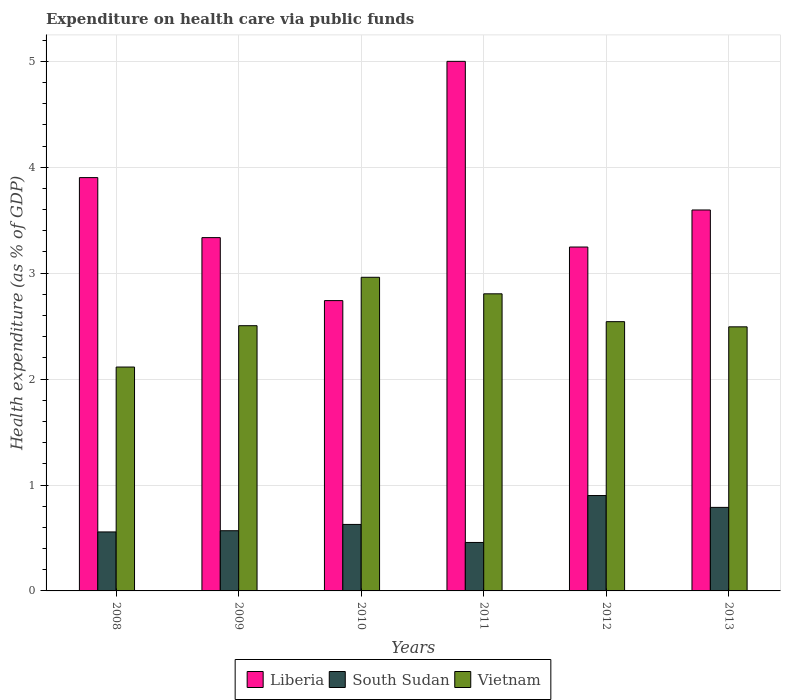How many different coloured bars are there?
Offer a terse response. 3. Are the number of bars on each tick of the X-axis equal?
Give a very brief answer. Yes. What is the label of the 2nd group of bars from the left?
Keep it short and to the point. 2009. In how many cases, is the number of bars for a given year not equal to the number of legend labels?
Offer a very short reply. 0. What is the expenditure made on health care in Vietnam in 2008?
Keep it short and to the point. 2.11. Across all years, what is the maximum expenditure made on health care in Liberia?
Offer a very short reply. 5. Across all years, what is the minimum expenditure made on health care in Vietnam?
Keep it short and to the point. 2.11. What is the total expenditure made on health care in Vietnam in the graph?
Your response must be concise. 15.42. What is the difference between the expenditure made on health care in Vietnam in 2010 and that in 2013?
Make the answer very short. 0.47. What is the difference between the expenditure made on health care in Liberia in 2008 and the expenditure made on health care in South Sudan in 2009?
Provide a succinct answer. 3.33. What is the average expenditure made on health care in Vietnam per year?
Offer a terse response. 2.57. In the year 2012, what is the difference between the expenditure made on health care in Liberia and expenditure made on health care in South Sudan?
Your response must be concise. 2.35. What is the ratio of the expenditure made on health care in Liberia in 2009 to that in 2011?
Give a very brief answer. 0.67. Is the expenditure made on health care in Vietnam in 2010 less than that in 2012?
Provide a succinct answer. No. What is the difference between the highest and the second highest expenditure made on health care in South Sudan?
Give a very brief answer. 0.11. What is the difference between the highest and the lowest expenditure made on health care in Vietnam?
Keep it short and to the point. 0.85. Is the sum of the expenditure made on health care in South Sudan in 2012 and 2013 greater than the maximum expenditure made on health care in Vietnam across all years?
Your answer should be very brief. No. What does the 3rd bar from the left in 2010 represents?
Give a very brief answer. Vietnam. What does the 1st bar from the right in 2010 represents?
Your answer should be compact. Vietnam. How many bars are there?
Ensure brevity in your answer.  18. Are all the bars in the graph horizontal?
Your answer should be very brief. No. What is the difference between two consecutive major ticks on the Y-axis?
Provide a short and direct response. 1. Does the graph contain grids?
Offer a terse response. Yes. How are the legend labels stacked?
Offer a terse response. Horizontal. What is the title of the graph?
Provide a succinct answer. Expenditure on health care via public funds. What is the label or title of the X-axis?
Make the answer very short. Years. What is the label or title of the Y-axis?
Your answer should be compact. Health expenditure (as % of GDP). What is the Health expenditure (as % of GDP) in Liberia in 2008?
Your answer should be very brief. 3.9. What is the Health expenditure (as % of GDP) of South Sudan in 2008?
Keep it short and to the point. 0.56. What is the Health expenditure (as % of GDP) in Vietnam in 2008?
Your response must be concise. 2.11. What is the Health expenditure (as % of GDP) of Liberia in 2009?
Provide a short and direct response. 3.34. What is the Health expenditure (as % of GDP) in South Sudan in 2009?
Provide a succinct answer. 0.57. What is the Health expenditure (as % of GDP) in Vietnam in 2009?
Your response must be concise. 2.5. What is the Health expenditure (as % of GDP) in Liberia in 2010?
Offer a terse response. 2.74. What is the Health expenditure (as % of GDP) in South Sudan in 2010?
Your response must be concise. 0.63. What is the Health expenditure (as % of GDP) of Vietnam in 2010?
Provide a succinct answer. 2.96. What is the Health expenditure (as % of GDP) in Liberia in 2011?
Ensure brevity in your answer.  5. What is the Health expenditure (as % of GDP) in South Sudan in 2011?
Ensure brevity in your answer.  0.46. What is the Health expenditure (as % of GDP) in Vietnam in 2011?
Offer a terse response. 2.81. What is the Health expenditure (as % of GDP) of Liberia in 2012?
Your answer should be very brief. 3.25. What is the Health expenditure (as % of GDP) of South Sudan in 2012?
Make the answer very short. 0.9. What is the Health expenditure (as % of GDP) of Vietnam in 2012?
Keep it short and to the point. 2.54. What is the Health expenditure (as % of GDP) of Liberia in 2013?
Ensure brevity in your answer.  3.6. What is the Health expenditure (as % of GDP) in South Sudan in 2013?
Ensure brevity in your answer.  0.79. What is the Health expenditure (as % of GDP) of Vietnam in 2013?
Provide a short and direct response. 2.49. Across all years, what is the maximum Health expenditure (as % of GDP) in Liberia?
Your answer should be compact. 5. Across all years, what is the maximum Health expenditure (as % of GDP) in South Sudan?
Ensure brevity in your answer.  0.9. Across all years, what is the maximum Health expenditure (as % of GDP) in Vietnam?
Provide a succinct answer. 2.96. Across all years, what is the minimum Health expenditure (as % of GDP) of Liberia?
Provide a short and direct response. 2.74. Across all years, what is the minimum Health expenditure (as % of GDP) in South Sudan?
Your answer should be very brief. 0.46. Across all years, what is the minimum Health expenditure (as % of GDP) of Vietnam?
Your answer should be compact. 2.11. What is the total Health expenditure (as % of GDP) in Liberia in the graph?
Give a very brief answer. 21.82. What is the total Health expenditure (as % of GDP) in South Sudan in the graph?
Your answer should be compact. 3.9. What is the total Health expenditure (as % of GDP) in Vietnam in the graph?
Keep it short and to the point. 15.42. What is the difference between the Health expenditure (as % of GDP) of Liberia in 2008 and that in 2009?
Provide a short and direct response. 0.57. What is the difference between the Health expenditure (as % of GDP) in South Sudan in 2008 and that in 2009?
Provide a succinct answer. -0.01. What is the difference between the Health expenditure (as % of GDP) of Vietnam in 2008 and that in 2009?
Offer a terse response. -0.39. What is the difference between the Health expenditure (as % of GDP) in Liberia in 2008 and that in 2010?
Provide a short and direct response. 1.16. What is the difference between the Health expenditure (as % of GDP) in South Sudan in 2008 and that in 2010?
Keep it short and to the point. -0.07. What is the difference between the Health expenditure (as % of GDP) in Vietnam in 2008 and that in 2010?
Make the answer very short. -0.85. What is the difference between the Health expenditure (as % of GDP) of Liberia in 2008 and that in 2011?
Make the answer very short. -1.1. What is the difference between the Health expenditure (as % of GDP) of South Sudan in 2008 and that in 2011?
Offer a very short reply. 0.1. What is the difference between the Health expenditure (as % of GDP) of Vietnam in 2008 and that in 2011?
Ensure brevity in your answer.  -0.69. What is the difference between the Health expenditure (as % of GDP) in Liberia in 2008 and that in 2012?
Ensure brevity in your answer.  0.66. What is the difference between the Health expenditure (as % of GDP) in South Sudan in 2008 and that in 2012?
Ensure brevity in your answer.  -0.34. What is the difference between the Health expenditure (as % of GDP) in Vietnam in 2008 and that in 2012?
Offer a terse response. -0.43. What is the difference between the Health expenditure (as % of GDP) of Liberia in 2008 and that in 2013?
Give a very brief answer. 0.31. What is the difference between the Health expenditure (as % of GDP) of South Sudan in 2008 and that in 2013?
Offer a very short reply. -0.23. What is the difference between the Health expenditure (as % of GDP) in Vietnam in 2008 and that in 2013?
Your answer should be compact. -0.38. What is the difference between the Health expenditure (as % of GDP) of Liberia in 2009 and that in 2010?
Your response must be concise. 0.59. What is the difference between the Health expenditure (as % of GDP) of South Sudan in 2009 and that in 2010?
Your answer should be compact. -0.06. What is the difference between the Health expenditure (as % of GDP) in Vietnam in 2009 and that in 2010?
Your answer should be compact. -0.46. What is the difference between the Health expenditure (as % of GDP) of Liberia in 2009 and that in 2011?
Make the answer very short. -1.66. What is the difference between the Health expenditure (as % of GDP) of South Sudan in 2009 and that in 2011?
Provide a succinct answer. 0.11. What is the difference between the Health expenditure (as % of GDP) of Vietnam in 2009 and that in 2011?
Your answer should be compact. -0.3. What is the difference between the Health expenditure (as % of GDP) in Liberia in 2009 and that in 2012?
Your response must be concise. 0.09. What is the difference between the Health expenditure (as % of GDP) in South Sudan in 2009 and that in 2012?
Keep it short and to the point. -0.33. What is the difference between the Health expenditure (as % of GDP) in Vietnam in 2009 and that in 2012?
Offer a very short reply. -0.04. What is the difference between the Health expenditure (as % of GDP) in Liberia in 2009 and that in 2013?
Give a very brief answer. -0.26. What is the difference between the Health expenditure (as % of GDP) of South Sudan in 2009 and that in 2013?
Keep it short and to the point. -0.22. What is the difference between the Health expenditure (as % of GDP) of Vietnam in 2009 and that in 2013?
Your answer should be compact. 0.01. What is the difference between the Health expenditure (as % of GDP) in Liberia in 2010 and that in 2011?
Offer a very short reply. -2.26. What is the difference between the Health expenditure (as % of GDP) in South Sudan in 2010 and that in 2011?
Offer a terse response. 0.17. What is the difference between the Health expenditure (as % of GDP) of Vietnam in 2010 and that in 2011?
Provide a succinct answer. 0.16. What is the difference between the Health expenditure (as % of GDP) in Liberia in 2010 and that in 2012?
Keep it short and to the point. -0.51. What is the difference between the Health expenditure (as % of GDP) in South Sudan in 2010 and that in 2012?
Make the answer very short. -0.27. What is the difference between the Health expenditure (as % of GDP) of Vietnam in 2010 and that in 2012?
Keep it short and to the point. 0.42. What is the difference between the Health expenditure (as % of GDP) in Liberia in 2010 and that in 2013?
Give a very brief answer. -0.86. What is the difference between the Health expenditure (as % of GDP) in South Sudan in 2010 and that in 2013?
Provide a short and direct response. -0.16. What is the difference between the Health expenditure (as % of GDP) of Vietnam in 2010 and that in 2013?
Offer a very short reply. 0.47. What is the difference between the Health expenditure (as % of GDP) in Liberia in 2011 and that in 2012?
Your answer should be compact. 1.75. What is the difference between the Health expenditure (as % of GDP) in South Sudan in 2011 and that in 2012?
Ensure brevity in your answer.  -0.44. What is the difference between the Health expenditure (as % of GDP) in Vietnam in 2011 and that in 2012?
Offer a terse response. 0.26. What is the difference between the Health expenditure (as % of GDP) in Liberia in 2011 and that in 2013?
Your response must be concise. 1.4. What is the difference between the Health expenditure (as % of GDP) in South Sudan in 2011 and that in 2013?
Provide a short and direct response. -0.33. What is the difference between the Health expenditure (as % of GDP) in Vietnam in 2011 and that in 2013?
Offer a terse response. 0.31. What is the difference between the Health expenditure (as % of GDP) of Liberia in 2012 and that in 2013?
Give a very brief answer. -0.35. What is the difference between the Health expenditure (as % of GDP) in South Sudan in 2012 and that in 2013?
Your answer should be compact. 0.11. What is the difference between the Health expenditure (as % of GDP) of Vietnam in 2012 and that in 2013?
Keep it short and to the point. 0.05. What is the difference between the Health expenditure (as % of GDP) of Liberia in 2008 and the Health expenditure (as % of GDP) of South Sudan in 2009?
Make the answer very short. 3.33. What is the difference between the Health expenditure (as % of GDP) in Liberia in 2008 and the Health expenditure (as % of GDP) in Vietnam in 2009?
Offer a very short reply. 1.4. What is the difference between the Health expenditure (as % of GDP) in South Sudan in 2008 and the Health expenditure (as % of GDP) in Vietnam in 2009?
Provide a succinct answer. -1.95. What is the difference between the Health expenditure (as % of GDP) of Liberia in 2008 and the Health expenditure (as % of GDP) of South Sudan in 2010?
Provide a succinct answer. 3.27. What is the difference between the Health expenditure (as % of GDP) of Liberia in 2008 and the Health expenditure (as % of GDP) of Vietnam in 2010?
Keep it short and to the point. 0.94. What is the difference between the Health expenditure (as % of GDP) in South Sudan in 2008 and the Health expenditure (as % of GDP) in Vietnam in 2010?
Offer a terse response. -2.4. What is the difference between the Health expenditure (as % of GDP) in Liberia in 2008 and the Health expenditure (as % of GDP) in South Sudan in 2011?
Offer a terse response. 3.44. What is the difference between the Health expenditure (as % of GDP) in Liberia in 2008 and the Health expenditure (as % of GDP) in Vietnam in 2011?
Give a very brief answer. 1.1. What is the difference between the Health expenditure (as % of GDP) of South Sudan in 2008 and the Health expenditure (as % of GDP) of Vietnam in 2011?
Offer a terse response. -2.25. What is the difference between the Health expenditure (as % of GDP) in Liberia in 2008 and the Health expenditure (as % of GDP) in South Sudan in 2012?
Your answer should be compact. 3. What is the difference between the Health expenditure (as % of GDP) of Liberia in 2008 and the Health expenditure (as % of GDP) of Vietnam in 2012?
Ensure brevity in your answer.  1.36. What is the difference between the Health expenditure (as % of GDP) in South Sudan in 2008 and the Health expenditure (as % of GDP) in Vietnam in 2012?
Give a very brief answer. -1.99. What is the difference between the Health expenditure (as % of GDP) in Liberia in 2008 and the Health expenditure (as % of GDP) in South Sudan in 2013?
Your answer should be compact. 3.11. What is the difference between the Health expenditure (as % of GDP) in Liberia in 2008 and the Health expenditure (as % of GDP) in Vietnam in 2013?
Give a very brief answer. 1.41. What is the difference between the Health expenditure (as % of GDP) of South Sudan in 2008 and the Health expenditure (as % of GDP) of Vietnam in 2013?
Give a very brief answer. -1.94. What is the difference between the Health expenditure (as % of GDP) of Liberia in 2009 and the Health expenditure (as % of GDP) of South Sudan in 2010?
Provide a short and direct response. 2.71. What is the difference between the Health expenditure (as % of GDP) in Liberia in 2009 and the Health expenditure (as % of GDP) in Vietnam in 2010?
Offer a terse response. 0.37. What is the difference between the Health expenditure (as % of GDP) of South Sudan in 2009 and the Health expenditure (as % of GDP) of Vietnam in 2010?
Offer a terse response. -2.39. What is the difference between the Health expenditure (as % of GDP) in Liberia in 2009 and the Health expenditure (as % of GDP) in South Sudan in 2011?
Make the answer very short. 2.88. What is the difference between the Health expenditure (as % of GDP) in Liberia in 2009 and the Health expenditure (as % of GDP) in Vietnam in 2011?
Keep it short and to the point. 0.53. What is the difference between the Health expenditure (as % of GDP) in South Sudan in 2009 and the Health expenditure (as % of GDP) in Vietnam in 2011?
Give a very brief answer. -2.24. What is the difference between the Health expenditure (as % of GDP) of Liberia in 2009 and the Health expenditure (as % of GDP) of South Sudan in 2012?
Your response must be concise. 2.44. What is the difference between the Health expenditure (as % of GDP) in Liberia in 2009 and the Health expenditure (as % of GDP) in Vietnam in 2012?
Offer a terse response. 0.79. What is the difference between the Health expenditure (as % of GDP) in South Sudan in 2009 and the Health expenditure (as % of GDP) in Vietnam in 2012?
Your answer should be compact. -1.97. What is the difference between the Health expenditure (as % of GDP) in Liberia in 2009 and the Health expenditure (as % of GDP) in South Sudan in 2013?
Keep it short and to the point. 2.55. What is the difference between the Health expenditure (as % of GDP) in Liberia in 2009 and the Health expenditure (as % of GDP) in Vietnam in 2013?
Give a very brief answer. 0.84. What is the difference between the Health expenditure (as % of GDP) of South Sudan in 2009 and the Health expenditure (as % of GDP) of Vietnam in 2013?
Offer a very short reply. -1.93. What is the difference between the Health expenditure (as % of GDP) in Liberia in 2010 and the Health expenditure (as % of GDP) in South Sudan in 2011?
Your answer should be very brief. 2.28. What is the difference between the Health expenditure (as % of GDP) of Liberia in 2010 and the Health expenditure (as % of GDP) of Vietnam in 2011?
Your answer should be compact. -0.06. What is the difference between the Health expenditure (as % of GDP) in South Sudan in 2010 and the Health expenditure (as % of GDP) in Vietnam in 2011?
Provide a succinct answer. -2.18. What is the difference between the Health expenditure (as % of GDP) in Liberia in 2010 and the Health expenditure (as % of GDP) in South Sudan in 2012?
Your answer should be very brief. 1.84. What is the difference between the Health expenditure (as % of GDP) of Liberia in 2010 and the Health expenditure (as % of GDP) of Vietnam in 2012?
Offer a very short reply. 0.2. What is the difference between the Health expenditure (as % of GDP) of South Sudan in 2010 and the Health expenditure (as % of GDP) of Vietnam in 2012?
Keep it short and to the point. -1.91. What is the difference between the Health expenditure (as % of GDP) in Liberia in 2010 and the Health expenditure (as % of GDP) in South Sudan in 2013?
Offer a very short reply. 1.95. What is the difference between the Health expenditure (as % of GDP) of Liberia in 2010 and the Health expenditure (as % of GDP) of Vietnam in 2013?
Provide a short and direct response. 0.25. What is the difference between the Health expenditure (as % of GDP) of South Sudan in 2010 and the Health expenditure (as % of GDP) of Vietnam in 2013?
Offer a terse response. -1.87. What is the difference between the Health expenditure (as % of GDP) of Liberia in 2011 and the Health expenditure (as % of GDP) of South Sudan in 2012?
Your response must be concise. 4.1. What is the difference between the Health expenditure (as % of GDP) in Liberia in 2011 and the Health expenditure (as % of GDP) in Vietnam in 2012?
Provide a succinct answer. 2.46. What is the difference between the Health expenditure (as % of GDP) of South Sudan in 2011 and the Health expenditure (as % of GDP) of Vietnam in 2012?
Ensure brevity in your answer.  -2.08. What is the difference between the Health expenditure (as % of GDP) of Liberia in 2011 and the Health expenditure (as % of GDP) of South Sudan in 2013?
Keep it short and to the point. 4.21. What is the difference between the Health expenditure (as % of GDP) in Liberia in 2011 and the Health expenditure (as % of GDP) in Vietnam in 2013?
Give a very brief answer. 2.51. What is the difference between the Health expenditure (as % of GDP) in South Sudan in 2011 and the Health expenditure (as % of GDP) in Vietnam in 2013?
Keep it short and to the point. -2.04. What is the difference between the Health expenditure (as % of GDP) in Liberia in 2012 and the Health expenditure (as % of GDP) in South Sudan in 2013?
Your response must be concise. 2.46. What is the difference between the Health expenditure (as % of GDP) in Liberia in 2012 and the Health expenditure (as % of GDP) in Vietnam in 2013?
Make the answer very short. 0.75. What is the difference between the Health expenditure (as % of GDP) in South Sudan in 2012 and the Health expenditure (as % of GDP) in Vietnam in 2013?
Offer a terse response. -1.59. What is the average Health expenditure (as % of GDP) of Liberia per year?
Your answer should be very brief. 3.64. What is the average Health expenditure (as % of GDP) of South Sudan per year?
Offer a terse response. 0.65. What is the average Health expenditure (as % of GDP) in Vietnam per year?
Make the answer very short. 2.57. In the year 2008, what is the difference between the Health expenditure (as % of GDP) of Liberia and Health expenditure (as % of GDP) of South Sudan?
Your response must be concise. 3.35. In the year 2008, what is the difference between the Health expenditure (as % of GDP) of Liberia and Health expenditure (as % of GDP) of Vietnam?
Offer a very short reply. 1.79. In the year 2008, what is the difference between the Health expenditure (as % of GDP) of South Sudan and Health expenditure (as % of GDP) of Vietnam?
Keep it short and to the point. -1.56. In the year 2009, what is the difference between the Health expenditure (as % of GDP) of Liberia and Health expenditure (as % of GDP) of South Sudan?
Offer a terse response. 2.77. In the year 2009, what is the difference between the Health expenditure (as % of GDP) of Liberia and Health expenditure (as % of GDP) of Vietnam?
Ensure brevity in your answer.  0.83. In the year 2009, what is the difference between the Health expenditure (as % of GDP) of South Sudan and Health expenditure (as % of GDP) of Vietnam?
Provide a succinct answer. -1.94. In the year 2010, what is the difference between the Health expenditure (as % of GDP) of Liberia and Health expenditure (as % of GDP) of South Sudan?
Provide a succinct answer. 2.11. In the year 2010, what is the difference between the Health expenditure (as % of GDP) in Liberia and Health expenditure (as % of GDP) in Vietnam?
Ensure brevity in your answer.  -0.22. In the year 2010, what is the difference between the Health expenditure (as % of GDP) in South Sudan and Health expenditure (as % of GDP) in Vietnam?
Make the answer very short. -2.33. In the year 2011, what is the difference between the Health expenditure (as % of GDP) of Liberia and Health expenditure (as % of GDP) of South Sudan?
Your answer should be very brief. 4.54. In the year 2011, what is the difference between the Health expenditure (as % of GDP) in Liberia and Health expenditure (as % of GDP) in Vietnam?
Your answer should be very brief. 2.19. In the year 2011, what is the difference between the Health expenditure (as % of GDP) of South Sudan and Health expenditure (as % of GDP) of Vietnam?
Provide a short and direct response. -2.35. In the year 2012, what is the difference between the Health expenditure (as % of GDP) of Liberia and Health expenditure (as % of GDP) of South Sudan?
Keep it short and to the point. 2.35. In the year 2012, what is the difference between the Health expenditure (as % of GDP) in Liberia and Health expenditure (as % of GDP) in Vietnam?
Keep it short and to the point. 0.7. In the year 2012, what is the difference between the Health expenditure (as % of GDP) of South Sudan and Health expenditure (as % of GDP) of Vietnam?
Make the answer very short. -1.64. In the year 2013, what is the difference between the Health expenditure (as % of GDP) in Liberia and Health expenditure (as % of GDP) in South Sudan?
Provide a succinct answer. 2.81. In the year 2013, what is the difference between the Health expenditure (as % of GDP) of Liberia and Health expenditure (as % of GDP) of Vietnam?
Keep it short and to the point. 1.1. In the year 2013, what is the difference between the Health expenditure (as % of GDP) of South Sudan and Health expenditure (as % of GDP) of Vietnam?
Make the answer very short. -1.7. What is the ratio of the Health expenditure (as % of GDP) of Liberia in 2008 to that in 2009?
Offer a very short reply. 1.17. What is the ratio of the Health expenditure (as % of GDP) in South Sudan in 2008 to that in 2009?
Ensure brevity in your answer.  0.98. What is the ratio of the Health expenditure (as % of GDP) of Vietnam in 2008 to that in 2009?
Your answer should be very brief. 0.84. What is the ratio of the Health expenditure (as % of GDP) of Liberia in 2008 to that in 2010?
Your answer should be compact. 1.42. What is the ratio of the Health expenditure (as % of GDP) in South Sudan in 2008 to that in 2010?
Keep it short and to the point. 0.89. What is the ratio of the Health expenditure (as % of GDP) of Vietnam in 2008 to that in 2010?
Give a very brief answer. 0.71. What is the ratio of the Health expenditure (as % of GDP) in Liberia in 2008 to that in 2011?
Your answer should be compact. 0.78. What is the ratio of the Health expenditure (as % of GDP) in South Sudan in 2008 to that in 2011?
Give a very brief answer. 1.22. What is the ratio of the Health expenditure (as % of GDP) of Vietnam in 2008 to that in 2011?
Make the answer very short. 0.75. What is the ratio of the Health expenditure (as % of GDP) in Liberia in 2008 to that in 2012?
Your answer should be very brief. 1.2. What is the ratio of the Health expenditure (as % of GDP) in South Sudan in 2008 to that in 2012?
Your response must be concise. 0.62. What is the ratio of the Health expenditure (as % of GDP) of Vietnam in 2008 to that in 2012?
Your answer should be compact. 0.83. What is the ratio of the Health expenditure (as % of GDP) in Liberia in 2008 to that in 2013?
Your response must be concise. 1.08. What is the ratio of the Health expenditure (as % of GDP) in South Sudan in 2008 to that in 2013?
Your answer should be compact. 0.71. What is the ratio of the Health expenditure (as % of GDP) of Vietnam in 2008 to that in 2013?
Ensure brevity in your answer.  0.85. What is the ratio of the Health expenditure (as % of GDP) in Liberia in 2009 to that in 2010?
Ensure brevity in your answer.  1.22. What is the ratio of the Health expenditure (as % of GDP) of South Sudan in 2009 to that in 2010?
Give a very brief answer. 0.91. What is the ratio of the Health expenditure (as % of GDP) in Vietnam in 2009 to that in 2010?
Offer a very short reply. 0.85. What is the ratio of the Health expenditure (as % of GDP) of Liberia in 2009 to that in 2011?
Your answer should be compact. 0.67. What is the ratio of the Health expenditure (as % of GDP) of South Sudan in 2009 to that in 2011?
Make the answer very short. 1.24. What is the ratio of the Health expenditure (as % of GDP) in Vietnam in 2009 to that in 2011?
Give a very brief answer. 0.89. What is the ratio of the Health expenditure (as % of GDP) in Liberia in 2009 to that in 2012?
Your response must be concise. 1.03. What is the ratio of the Health expenditure (as % of GDP) in South Sudan in 2009 to that in 2012?
Keep it short and to the point. 0.63. What is the ratio of the Health expenditure (as % of GDP) of Liberia in 2009 to that in 2013?
Offer a very short reply. 0.93. What is the ratio of the Health expenditure (as % of GDP) in South Sudan in 2009 to that in 2013?
Your answer should be compact. 0.72. What is the ratio of the Health expenditure (as % of GDP) of Vietnam in 2009 to that in 2013?
Offer a very short reply. 1. What is the ratio of the Health expenditure (as % of GDP) in Liberia in 2010 to that in 2011?
Your response must be concise. 0.55. What is the ratio of the Health expenditure (as % of GDP) in South Sudan in 2010 to that in 2011?
Offer a very short reply. 1.37. What is the ratio of the Health expenditure (as % of GDP) of Vietnam in 2010 to that in 2011?
Give a very brief answer. 1.06. What is the ratio of the Health expenditure (as % of GDP) of Liberia in 2010 to that in 2012?
Offer a very short reply. 0.84. What is the ratio of the Health expenditure (as % of GDP) in South Sudan in 2010 to that in 2012?
Ensure brevity in your answer.  0.7. What is the ratio of the Health expenditure (as % of GDP) in Vietnam in 2010 to that in 2012?
Offer a terse response. 1.16. What is the ratio of the Health expenditure (as % of GDP) in Liberia in 2010 to that in 2013?
Offer a terse response. 0.76. What is the ratio of the Health expenditure (as % of GDP) of South Sudan in 2010 to that in 2013?
Offer a very short reply. 0.8. What is the ratio of the Health expenditure (as % of GDP) of Vietnam in 2010 to that in 2013?
Keep it short and to the point. 1.19. What is the ratio of the Health expenditure (as % of GDP) in Liberia in 2011 to that in 2012?
Ensure brevity in your answer.  1.54. What is the ratio of the Health expenditure (as % of GDP) in South Sudan in 2011 to that in 2012?
Provide a succinct answer. 0.51. What is the ratio of the Health expenditure (as % of GDP) of Vietnam in 2011 to that in 2012?
Your response must be concise. 1.1. What is the ratio of the Health expenditure (as % of GDP) in Liberia in 2011 to that in 2013?
Make the answer very short. 1.39. What is the ratio of the Health expenditure (as % of GDP) in South Sudan in 2011 to that in 2013?
Your response must be concise. 0.58. What is the ratio of the Health expenditure (as % of GDP) of Vietnam in 2011 to that in 2013?
Your answer should be compact. 1.12. What is the ratio of the Health expenditure (as % of GDP) in Liberia in 2012 to that in 2013?
Offer a terse response. 0.9. What is the ratio of the Health expenditure (as % of GDP) of South Sudan in 2012 to that in 2013?
Offer a very short reply. 1.14. What is the ratio of the Health expenditure (as % of GDP) in Vietnam in 2012 to that in 2013?
Your answer should be very brief. 1.02. What is the difference between the highest and the second highest Health expenditure (as % of GDP) in Liberia?
Ensure brevity in your answer.  1.1. What is the difference between the highest and the second highest Health expenditure (as % of GDP) in South Sudan?
Provide a short and direct response. 0.11. What is the difference between the highest and the second highest Health expenditure (as % of GDP) of Vietnam?
Keep it short and to the point. 0.16. What is the difference between the highest and the lowest Health expenditure (as % of GDP) of Liberia?
Give a very brief answer. 2.26. What is the difference between the highest and the lowest Health expenditure (as % of GDP) in South Sudan?
Ensure brevity in your answer.  0.44. What is the difference between the highest and the lowest Health expenditure (as % of GDP) in Vietnam?
Provide a succinct answer. 0.85. 